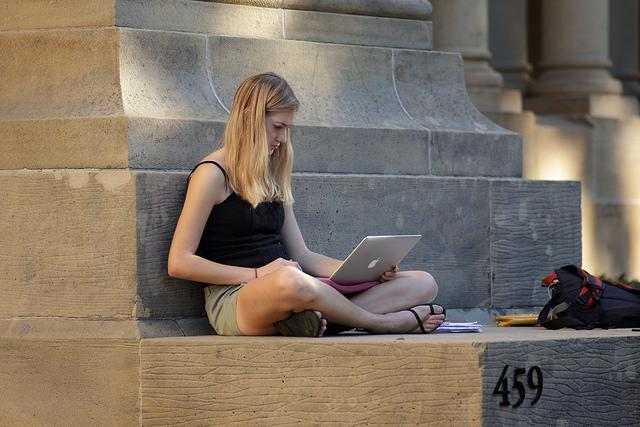How might this person easily look up the phone number for a taxi?

Choices:
A) check purse
B) ask passersby
C) google it
D) yellow pages google it 